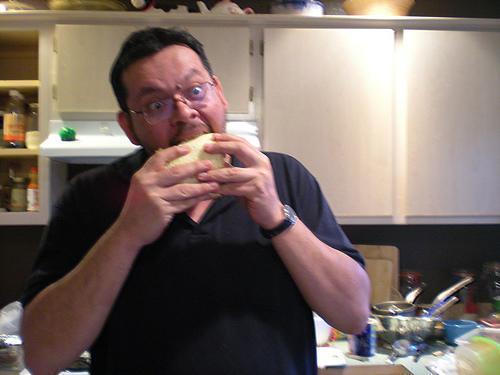How many people are wearing watch?
Give a very brief answer. 1. 